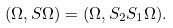<formula> <loc_0><loc_0><loc_500><loc_500>( \Omega , S \Omega ) = ( \Omega , S _ { 2 } S _ { 1 } \Omega ) .</formula> 